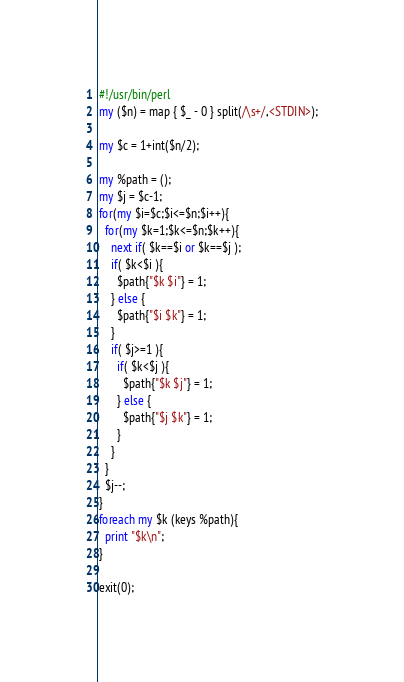<code> <loc_0><loc_0><loc_500><loc_500><_Perl_>#!/usr/bin/perl
my ($n) = map { $_ - 0 } split(/\s+/,<STDIN>);

my $c = 1+int($n/2);

my %path = ();
my $j = $c-1;
for(my $i=$c;$i<=$n;$i++){
  for(my $k=1;$k<=$n;$k++){
    next if( $k==$i or $k==$j );
    if( $k<$i ){
      $path{"$k $i"} = 1;
    } else {
      $path{"$i $k"} = 1;
    }
    if( $j>=1 ){
      if( $k<$j ){
        $path{"$k $j"} = 1;
      } else {
        $path{"$j $k"} = 1;
      }
    }
  }
  $j--;
}
foreach my $k (keys %path){
  print "$k\n";
}

exit(0);

</code> 